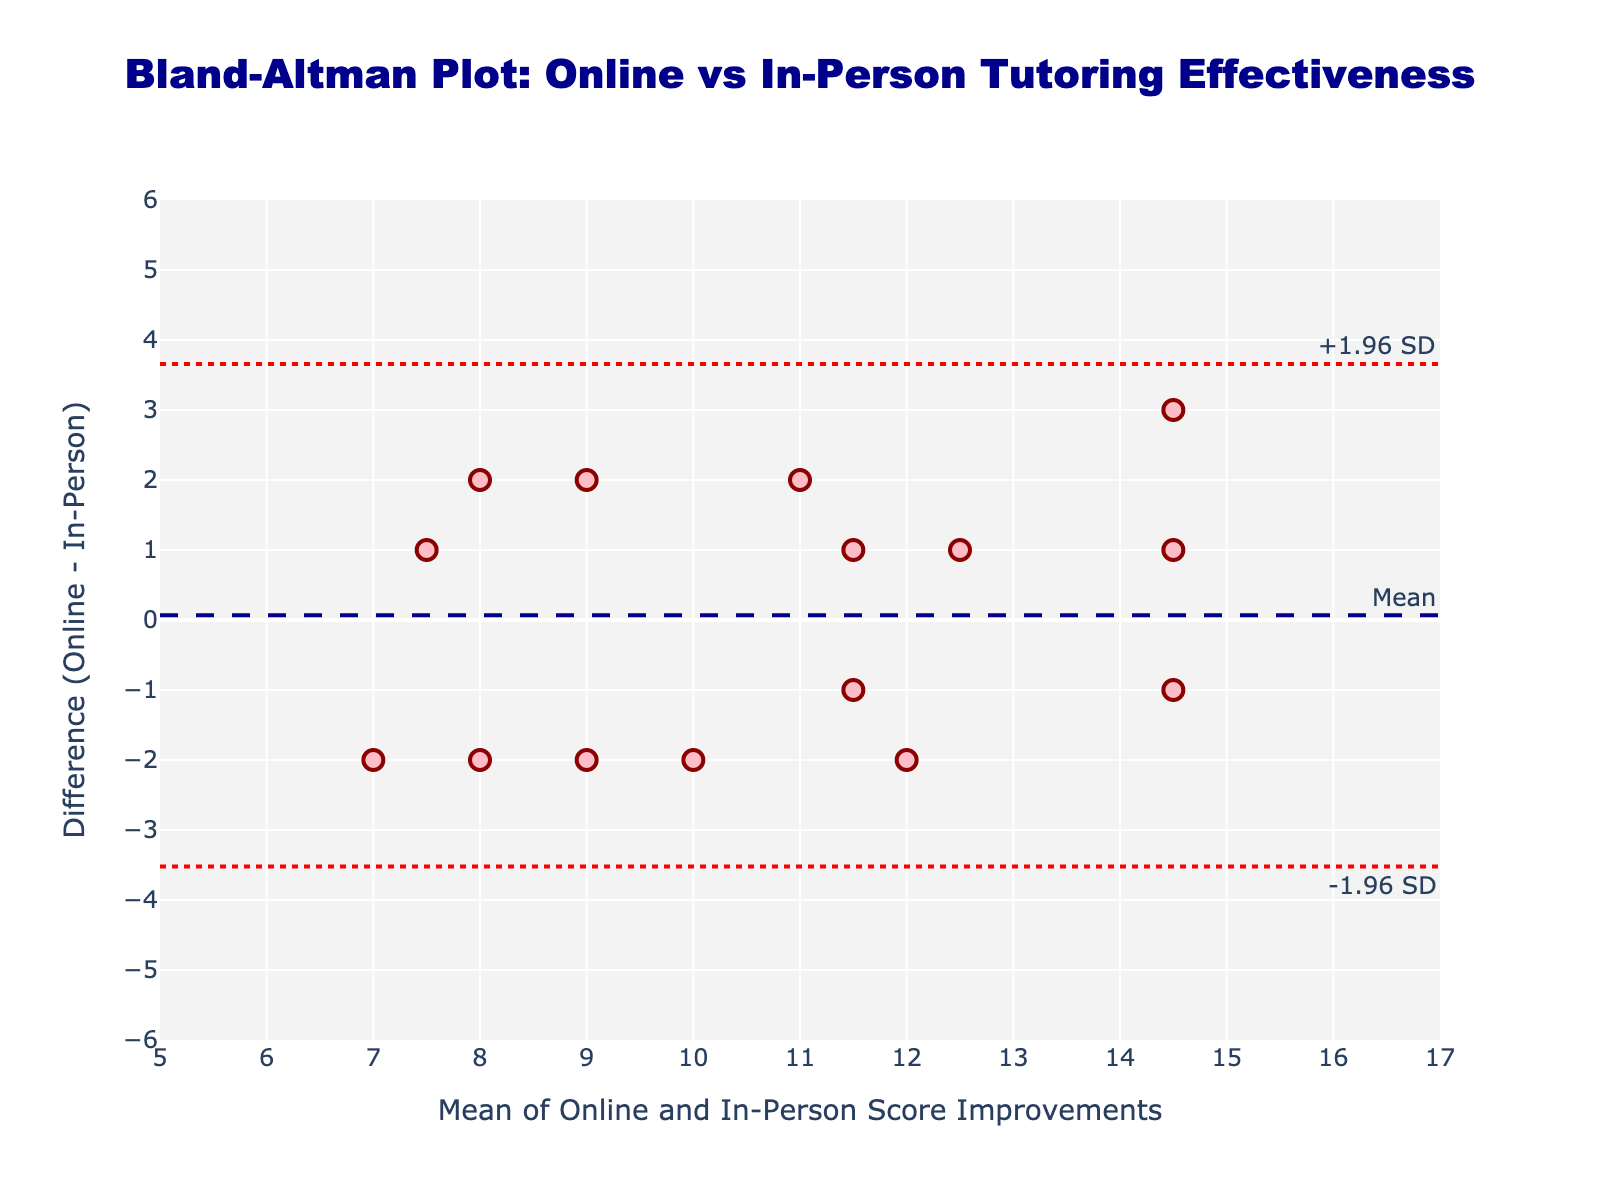what is the title of the plot? The title of the plot is usually placed at the top. Here, the text at the top center reads "Bland-Altman Plot: Online vs In-Person Tutoring Effectiveness".
Answer: Bland-Altman Plot: Online vs In-Person Tutoring Effectiveness What is the y-axis representing? The y-axis represents the "Difference (Online - In-Person)" in score improvements.
Answer: Difference (Online - In-Person) How many data points are plotted? Each data point corresponds to a student's score improvement difference and mean. Counting the points on the plot or verifying against the data indicates 15 students are represented.
Answer: 15 How is the mean difference visually represented? The mean difference is represented by a horizontal dashed line labeled "Mean".
Answer: A horizontal dashed line What colors are used for the scatter plot markers? The scatter plot markers are pink with dark red outlines.
Answer: Pink with dark red outlines Is the average online score improvement higher or lower than the in-person score improvement? By looking at the vertical positioning of many points, the average difference line is slightly below zero. This indicates that online scores are generally slightly lower than in-person scores.
Answer: Lower What are the upper and lower limits of agreement? The upper and lower limits are represented by two horizontal dotted lines. These are around -2.4 for the lower limit and +2.4 for the upper limit.
Answer: -2.4 and +2.4 What can you infer if a point lies near the horizontal mean line? If a point lies near the horizontal mean line, the improvement in test scores for that student is almost the same for both online and in-person tutoring sessions.
Answer: Similar improvements for both tutoring methods What does a negative difference on the y-axis imply about a student's score improvement? A negative difference on the y-axis implies that the student scored better in in-person sessions compared to online sessions.
Answer: Better in in-person sessions What does a large spread in the differences indicate about the variability in tutoring effectiveness? A large spread in differences suggests high variability in how different students responded to online versus in-person tutoring.
Answer: High variability 